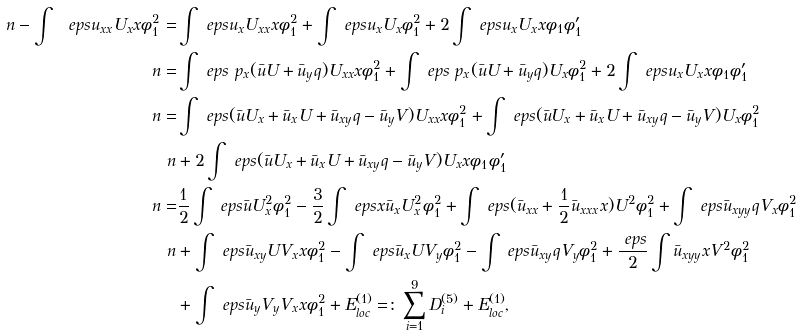Convert formula to latex. <formula><loc_0><loc_0><loc_500><loc_500>\ n - \int \ e p s u _ { x x } U _ { x } x \phi _ { 1 } ^ { 2 } = & \int \ e p s u _ { x } U _ { x x } x \phi _ { 1 } ^ { 2 } + \int \ e p s u _ { x } U _ { x } \phi _ { 1 } ^ { 2 } + 2 \int \ e p s u _ { x } U _ { x } x \phi _ { 1 } \phi _ { 1 } ^ { \prime } \\ \ n = & \int \ e p s \ p _ { x } ( \bar { u } U + \bar { u } _ { y } q ) U _ { x x } x \phi _ { 1 } ^ { 2 } + \int \ e p s \ p _ { x } ( \bar { u } U + \bar { u } _ { y } q ) U _ { x } \phi _ { 1 } ^ { 2 } + 2 \int \ e p s u _ { x } U _ { x } x \phi _ { 1 } \phi _ { 1 } ^ { \prime } \\ \ n = & \int \ e p s ( \bar { u } U _ { x } + \bar { u } _ { x } U + \bar { u } _ { x y } q - \bar { u } _ { y } V ) U _ { x x } x \phi _ { 1 } ^ { 2 } + \int \ e p s ( \bar { u } U _ { x } + \bar { u } _ { x } U + \bar { u } _ { x y } q - \bar { u } _ { y } V ) U _ { x } \phi _ { 1 } ^ { 2 } \\ \ n & + 2 \int \ e p s ( \bar { u } U _ { x } + \bar { u } _ { x } U + \bar { u } _ { x y } q - \bar { u } _ { y } V ) U _ { x } x \phi _ { 1 } \phi _ { 1 } ^ { \prime } \\ \ n = & \frac { 1 } { 2 } \int \ e p s \bar { u } U _ { x } ^ { 2 } \phi _ { 1 } ^ { 2 } - \frac { 3 } { 2 } \int \ e p s x \bar { u } _ { x } U _ { x } ^ { 2 } \phi _ { 1 } ^ { 2 } + \int \ e p s ( \bar { u } _ { x x } + \frac { 1 } { 2 } \bar { u } _ { x x x } x ) U ^ { 2 } \phi _ { 1 } ^ { 2 } + \int \ e p s \bar { u } _ { x y y } q V _ { x } \phi _ { 1 } ^ { 2 } \\ \ n & + \int \ e p s \bar { u } _ { x y } U V _ { x } x \phi _ { 1 } ^ { 2 } - \int \ e p s \bar { u } _ { x } U V _ { y } \phi _ { 1 } ^ { 2 } - \int \ e p s \bar { u } _ { x y } q V _ { y } \phi _ { 1 } ^ { 2 } + \frac { \ e p s } { 2 } \int \bar { u } _ { x y y } x V ^ { 2 } \phi _ { 1 } ^ { 2 } \\ & + \int \ e p s \bar { u } _ { y } V _ { y } V _ { x } x \phi _ { 1 } ^ { 2 } + E _ { l o c } ^ { ( 1 ) } = \colon \sum _ { i = 1 } ^ { 9 } D ^ { ( 5 ) } _ { i } + E ^ { ( 1 ) } _ { l o c } ,</formula> 